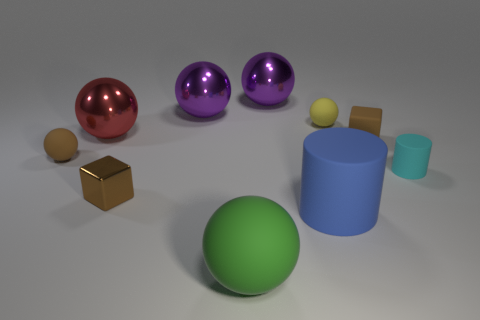Are there any other large cylinders of the same color as the large rubber cylinder?
Ensure brevity in your answer.  No. Are there any big matte cylinders?
Ensure brevity in your answer.  Yes. There is a cylinder on the left side of the cyan rubber cylinder; is it the same size as the red metallic thing?
Keep it short and to the point. Yes. Are there fewer small cyan rubber cylinders than gray shiny cylinders?
Your answer should be very brief. No. There is a tiny matte thing behind the brown rubber thing behind the small rubber sphere in front of the small matte cube; what shape is it?
Your response must be concise. Sphere. Are there any small brown objects that have the same material as the small brown sphere?
Provide a succinct answer. Yes. Do the matte ball that is in front of the tiny cyan thing and the small cube behind the cyan cylinder have the same color?
Your answer should be compact. No. Are there fewer tiny cyan matte cylinders in front of the large green sphere than tiny yellow metallic objects?
Give a very brief answer. No. What number of things are either rubber objects or large purple shiny spheres that are to the left of the large green object?
Your response must be concise. 7. What color is the cube that is the same material as the large blue thing?
Provide a succinct answer. Brown. 